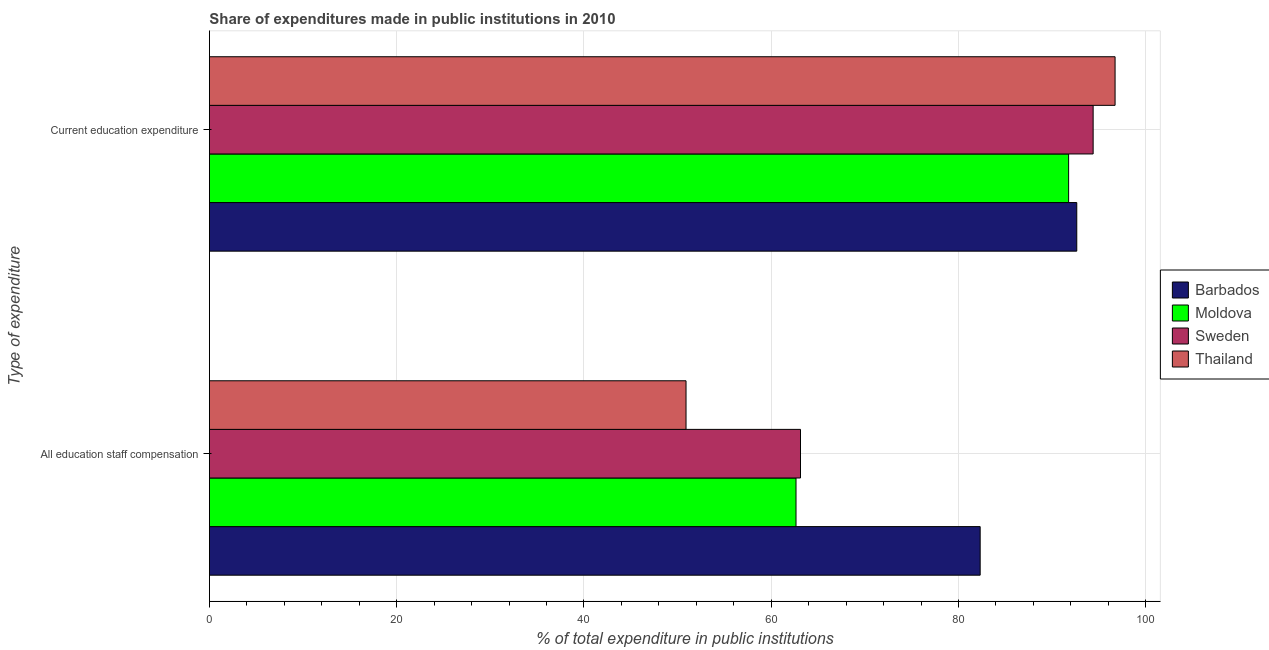How many different coloured bars are there?
Your answer should be compact. 4. Are the number of bars per tick equal to the number of legend labels?
Your response must be concise. Yes. Are the number of bars on each tick of the Y-axis equal?
Your answer should be very brief. Yes. What is the label of the 1st group of bars from the top?
Offer a terse response. Current education expenditure. What is the expenditure in education in Sweden?
Keep it short and to the point. 94.38. Across all countries, what is the maximum expenditure in staff compensation?
Make the answer very short. 82.31. Across all countries, what is the minimum expenditure in education?
Your response must be concise. 91.76. In which country was the expenditure in staff compensation maximum?
Make the answer very short. Barbados. In which country was the expenditure in education minimum?
Offer a very short reply. Moldova. What is the total expenditure in education in the graph?
Your answer should be very brief. 375.49. What is the difference between the expenditure in staff compensation in Thailand and that in Moldova?
Offer a terse response. -11.75. What is the difference between the expenditure in education in Thailand and the expenditure in staff compensation in Sweden?
Provide a succinct answer. 33.6. What is the average expenditure in staff compensation per country?
Provide a short and direct response. 64.75. What is the difference between the expenditure in staff compensation and expenditure in education in Thailand?
Keep it short and to the point. -45.82. In how many countries, is the expenditure in education greater than 12 %?
Keep it short and to the point. 4. What is the ratio of the expenditure in staff compensation in Sweden to that in Moldova?
Offer a very short reply. 1.01. Is the expenditure in education in Moldova less than that in Sweden?
Give a very brief answer. Yes. In how many countries, is the expenditure in staff compensation greater than the average expenditure in staff compensation taken over all countries?
Provide a short and direct response. 1. What does the 2nd bar from the bottom in Current education expenditure represents?
Your answer should be very brief. Moldova. How many bars are there?
Make the answer very short. 8. Does the graph contain any zero values?
Your answer should be very brief. No. How are the legend labels stacked?
Provide a succinct answer. Vertical. What is the title of the graph?
Provide a succinct answer. Share of expenditures made in public institutions in 2010. Does "Armenia" appear as one of the legend labels in the graph?
Your answer should be very brief. No. What is the label or title of the X-axis?
Give a very brief answer. % of total expenditure in public institutions. What is the label or title of the Y-axis?
Your response must be concise. Type of expenditure. What is the % of total expenditure in public institutions of Barbados in All education staff compensation?
Keep it short and to the point. 82.31. What is the % of total expenditure in public institutions of Moldova in All education staff compensation?
Offer a terse response. 62.65. What is the % of total expenditure in public institutions of Sweden in All education staff compensation?
Provide a short and direct response. 63.13. What is the % of total expenditure in public institutions of Thailand in All education staff compensation?
Offer a terse response. 50.9. What is the % of total expenditure in public institutions in Barbados in Current education expenditure?
Keep it short and to the point. 92.63. What is the % of total expenditure in public institutions of Moldova in Current education expenditure?
Give a very brief answer. 91.76. What is the % of total expenditure in public institutions of Sweden in Current education expenditure?
Provide a short and direct response. 94.38. What is the % of total expenditure in public institutions of Thailand in Current education expenditure?
Provide a short and direct response. 96.72. Across all Type of expenditure, what is the maximum % of total expenditure in public institutions of Barbados?
Your response must be concise. 92.63. Across all Type of expenditure, what is the maximum % of total expenditure in public institutions in Moldova?
Your answer should be very brief. 91.76. Across all Type of expenditure, what is the maximum % of total expenditure in public institutions of Sweden?
Provide a succinct answer. 94.38. Across all Type of expenditure, what is the maximum % of total expenditure in public institutions in Thailand?
Provide a short and direct response. 96.72. Across all Type of expenditure, what is the minimum % of total expenditure in public institutions in Barbados?
Provide a short and direct response. 82.31. Across all Type of expenditure, what is the minimum % of total expenditure in public institutions of Moldova?
Keep it short and to the point. 62.65. Across all Type of expenditure, what is the minimum % of total expenditure in public institutions in Sweden?
Your response must be concise. 63.13. Across all Type of expenditure, what is the minimum % of total expenditure in public institutions in Thailand?
Ensure brevity in your answer.  50.9. What is the total % of total expenditure in public institutions in Barbados in the graph?
Provide a short and direct response. 174.94. What is the total % of total expenditure in public institutions in Moldova in the graph?
Your response must be concise. 154.41. What is the total % of total expenditure in public institutions of Sweden in the graph?
Provide a succinct answer. 157.5. What is the total % of total expenditure in public institutions of Thailand in the graph?
Ensure brevity in your answer.  147.62. What is the difference between the % of total expenditure in public institutions of Barbados in All education staff compensation and that in Current education expenditure?
Offer a very short reply. -10.32. What is the difference between the % of total expenditure in public institutions in Moldova in All education staff compensation and that in Current education expenditure?
Your response must be concise. -29.11. What is the difference between the % of total expenditure in public institutions of Sweden in All education staff compensation and that in Current education expenditure?
Keep it short and to the point. -31.25. What is the difference between the % of total expenditure in public institutions in Thailand in All education staff compensation and that in Current education expenditure?
Your answer should be very brief. -45.82. What is the difference between the % of total expenditure in public institutions of Barbados in All education staff compensation and the % of total expenditure in public institutions of Moldova in Current education expenditure?
Keep it short and to the point. -9.45. What is the difference between the % of total expenditure in public institutions of Barbados in All education staff compensation and the % of total expenditure in public institutions of Sweden in Current education expenditure?
Offer a terse response. -12.07. What is the difference between the % of total expenditure in public institutions in Barbados in All education staff compensation and the % of total expenditure in public institutions in Thailand in Current education expenditure?
Offer a very short reply. -14.41. What is the difference between the % of total expenditure in public institutions of Moldova in All education staff compensation and the % of total expenditure in public institutions of Sweden in Current education expenditure?
Ensure brevity in your answer.  -31.73. What is the difference between the % of total expenditure in public institutions in Moldova in All education staff compensation and the % of total expenditure in public institutions in Thailand in Current education expenditure?
Offer a very short reply. -34.08. What is the difference between the % of total expenditure in public institutions in Sweden in All education staff compensation and the % of total expenditure in public institutions in Thailand in Current education expenditure?
Offer a very short reply. -33.6. What is the average % of total expenditure in public institutions in Barbados per Type of expenditure?
Your answer should be compact. 87.47. What is the average % of total expenditure in public institutions in Moldova per Type of expenditure?
Your answer should be very brief. 77.2. What is the average % of total expenditure in public institutions in Sweden per Type of expenditure?
Your answer should be compact. 78.75. What is the average % of total expenditure in public institutions of Thailand per Type of expenditure?
Your answer should be very brief. 73.81. What is the difference between the % of total expenditure in public institutions in Barbados and % of total expenditure in public institutions in Moldova in All education staff compensation?
Offer a terse response. 19.67. What is the difference between the % of total expenditure in public institutions in Barbados and % of total expenditure in public institutions in Sweden in All education staff compensation?
Keep it short and to the point. 19.19. What is the difference between the % of total expenditure in public institutions of Barbados and % of total expenditure in public institutions of Thailand in All education staff compensation?
Offer a terse response. 31.41. What is the difference between the % of total expenditure in public institutions of Moldova and % of total expenditure in public institutions of Sweden in All education staff compensation?
Keep it short and to the point. -0.48. What is the difference between the % of total expenditure in public institutions in Moldova and % of total expenditure in public institutions in Thailand in All education staff compensation?
Make the answer very short. 11.75. What is the difference between the % of total expenditure in public institutions in Sweden and % of total expenditure in public institutions in Thailand in All education staff compensation?
Ensure brevity in your answer.  12.22. What is the difference between the % of total expenditure in public institutions of Barbados and % of total expenditure in public institutions of Moldova in Current education expenditure?
Your response must be concise. 0.87. What is the difference between the % of total expenditure in public institutions of Barbados and % of total expenditure in public institutions of Sweden in Current education expenditure?
Give a very brief answer. -1.75. What is the difference between the % of total expenditure in public institutions of Barbados and % of total expenditure in public institutions of Thailand in Current education expenditure?
Ensure brevity in your answer.  -4.09. What is the difference between the % of total expenditure in public institutions of Moldova and % of total expenditure in public institutions of Sweden in Current education expenditure?
Provide a short and direct response. -2.62. What is the difference between the % of total expenditure in public institutions of Moldova and % of total expenditure in public institutions of Thailand in Current education expenditure?
Keep it short and to the point. -4.96. What is the difference between the % of total expenditure in public institutions of Sweden and % of total expenditure in public institutions of Thailand in Current education expenditure?
Your response must be concise. -2.34. What is the ratio of the % of total expenditure in public institutions of Barbados in All education staff compensation to that in Current education expenditure?
Provide a short and direct response. 0.89. What is the ratio of the % of total expenditure in public institutions in Moldova in All education staff compensation to that in Current education expenditure?
Ensure brevity in your answer.  0.68. What is the ratio of the % of total expenditure in public institutions in Sweden in All education staff compensation to that in Current education expenditure?
Offer a very short reply. 0.67. What is the ratio of the % of total expenditure in public institutions in Thailand in All education staff compensation to that in Current education expenditure?
Offer a terse response. 0.53. What is the difference between the highest and the second highest % of total expenditure in public institutions in Barbados?
Your answer should be very brief. 10.32. What is the difference between the highest and the second highest % of total expenditure in public institutions in Moldova?
Your answer should be compact. 29.11. What is the difference between the highest and the second highest % of total expenditure in public institutions of Sweden?
Keep it short and to the point. 31.25. What is the difference between the highest and the second highest % of total expenditure in public institutions in Thailand?
Provide a short and direct response. 45.82. What is the difference between the highest and the lowest % of total expenditure in public institutions in Barbados?
Your answer should be very brief. 10.32. What is the difference between the highest and the lowest % of total expenditure in public institutions of Moldova?
Ensure brevity in your answer.  29.11. What is the difference between the highest and the lowest % of total expenditure in public institutions of Sweden?
Provide a succinct answer. 31.25. What is the difference between the highest and the lowest % of total expenditure in public institutions in Thailand?
Ensure brevity in your answer.  45.82. 